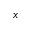<formula> <loc_0><loc_0><loc_500><loc_500>x</formula> 